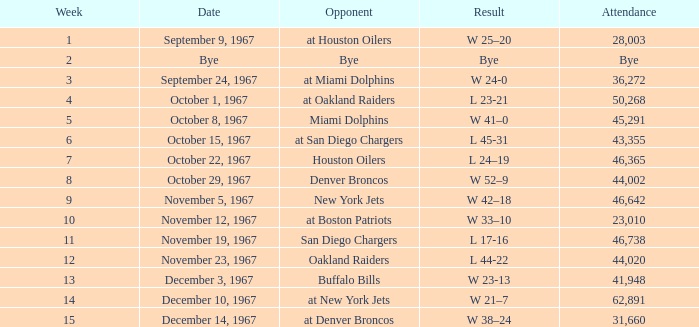What was the date of the game after week 5 against the Houston Oilers? October 22, 1967. 